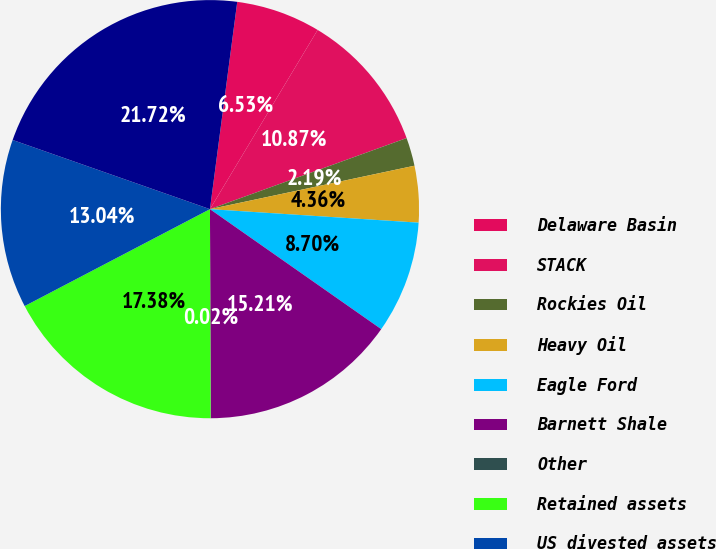Convert chart to OTSL. <chart><loc_0><loc_0><loc_500><loc_500><pie_chart><fcel>Delaware Basin<fcel>STACK<fcel>Rockies Oil<fcel>Heavy Oil<fcel>Eagle Ford<fcel>Barnett Shale<fcel>Other<fcel>Retained assets<fcel>US divested assets<fcel>Total<nl><fcel>6.53%<fcel>10.87%<fcel>2.19%<fcel>4.36%<fcel>8.7%<fcel>15.21%<fcel>0.02%<fcel>17.38%<fcel>13.04%<fcel>21.72%<nl></chart> 